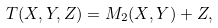Convert formula to latex. <formula><loc_0><loc_0><loc_500><loc_500>T ( X , Y , Z ) = M _ { 2 } ( X , Y ) + Z ,</formula> 